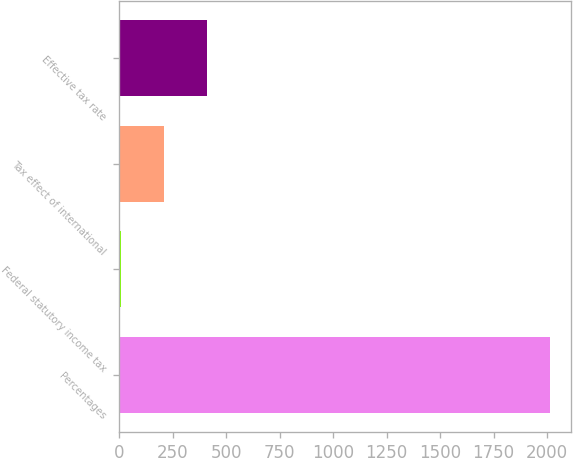Convert chart to OTSL. <chart><loc_0><loc_0><loc_500><loc_500><bar_chart><fcel>Percentages<fcel>Federal statutory income tax<fcel>Tax effect of international<fcel>Effective tax rate<nl><fcel>2013<fcel>7.8<fcel>208.32<fcel>408.84<nl></chart> 